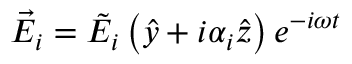<formula> <loc_0><loc_0><loc_500><loc_500>\vec { E } _ { i } = \tilde { E } _ { i } \left ( \hat { y } + i \alpha _ { i } \hat { z } \right ) e ^ { - i \omega t }</formula> 